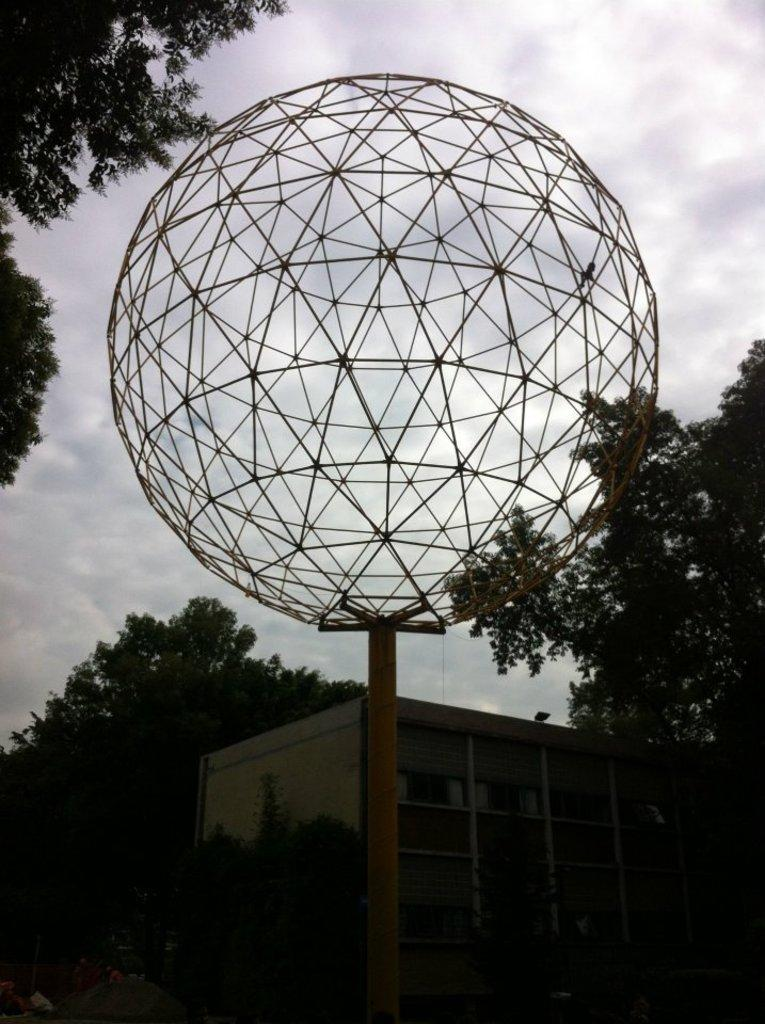What type of metal object can be seen in the image? There is a metal object in a circular shape in the image. What other objects are present in the image? There is a pole, plants, a building, and trees in the image. What is visible in the background of the image? The sky with clouds is visible in the background of the image. What type of scissors are being used to cut the week in the image? There are no scissors or any reference to a week in the image. 